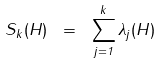Convert formula to latex. <formula><loc_0><loc_0><loc_500><loc_500>S _ { k } ( H ) \ = \ \sum _ { j = 1 } ^ { k } \lambda _ { j } ( H )</formula> 